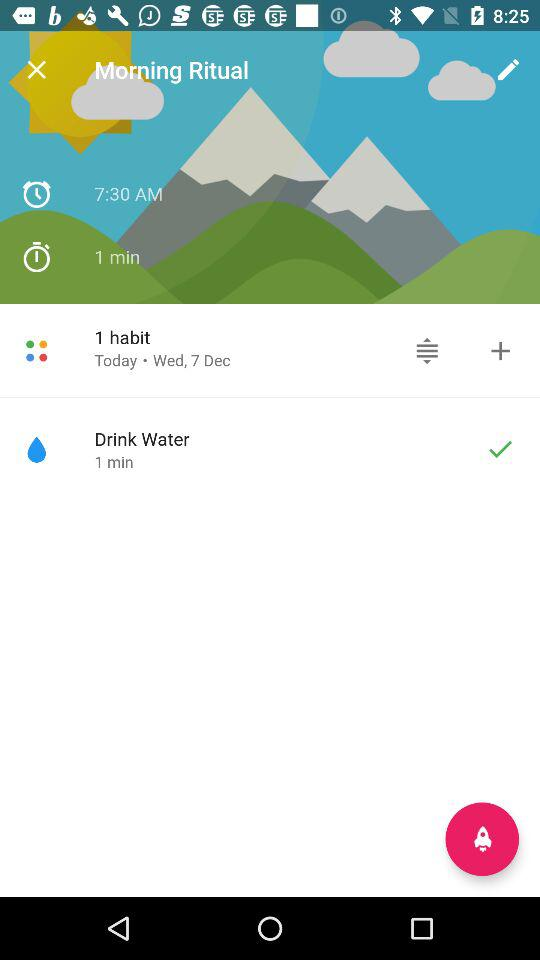What is the duration of "Morning Ritual"? The duration is 1 minute. 